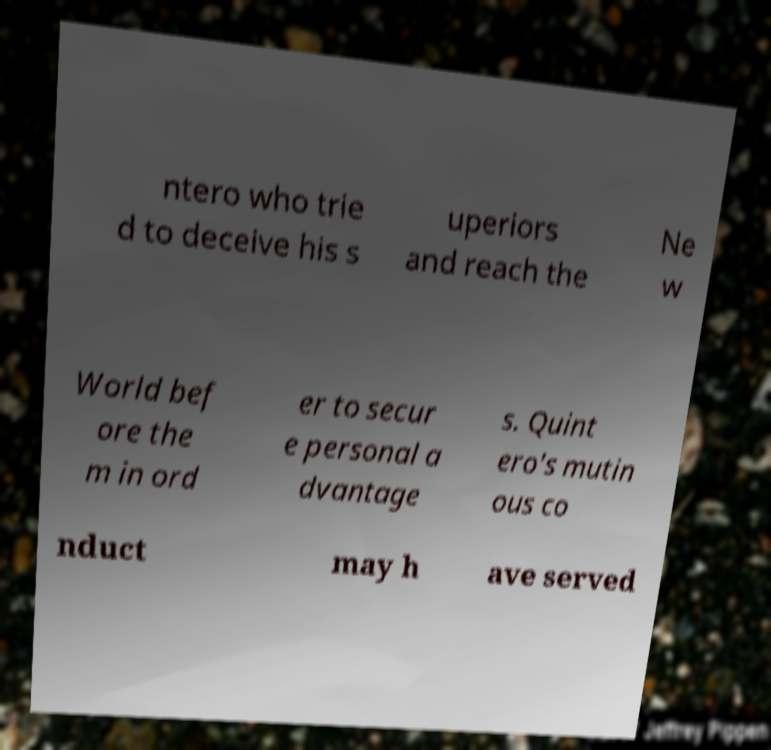Could you assist in decoding the text presented in this image and type it out clearly? ntero who trie d to deceive his s uperiors and reach the Ne w World bef ore the m in ord er to secur e personal a dvantage s. Quint ero's mutin ous co nduct may h ave served 